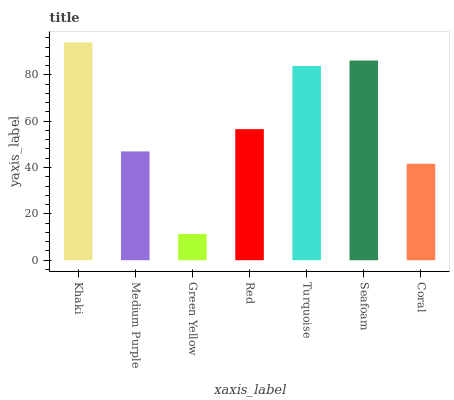Is Green Yellow the minimum?
Answer yes or no. Yes. Is Khaki the maximum?
Answer yes or no. Yes. Is Medium Purple the minimum?
Answer yes or no. No. Is Medium Purple the maximum?
Answer yes or no. No. Is Khaki greater than Medium Purple?
Answer yes or no. Yes. Is Medium Purple less than Khaki?
Answer yes or no. Yes. Is Medium Purple greater than Khaki?
Answer yes or no. No. Is Khaki less than Medium Purple?
Answer yes or no. No. Is Red the high median?
Answer yes or no. Yes. Is Red the low median?
Answer yes or no. Yes. Is Seafoam the high median?
Answer yes or no. No. Is Green Yellow the low median?
Answer yes or no. No. 